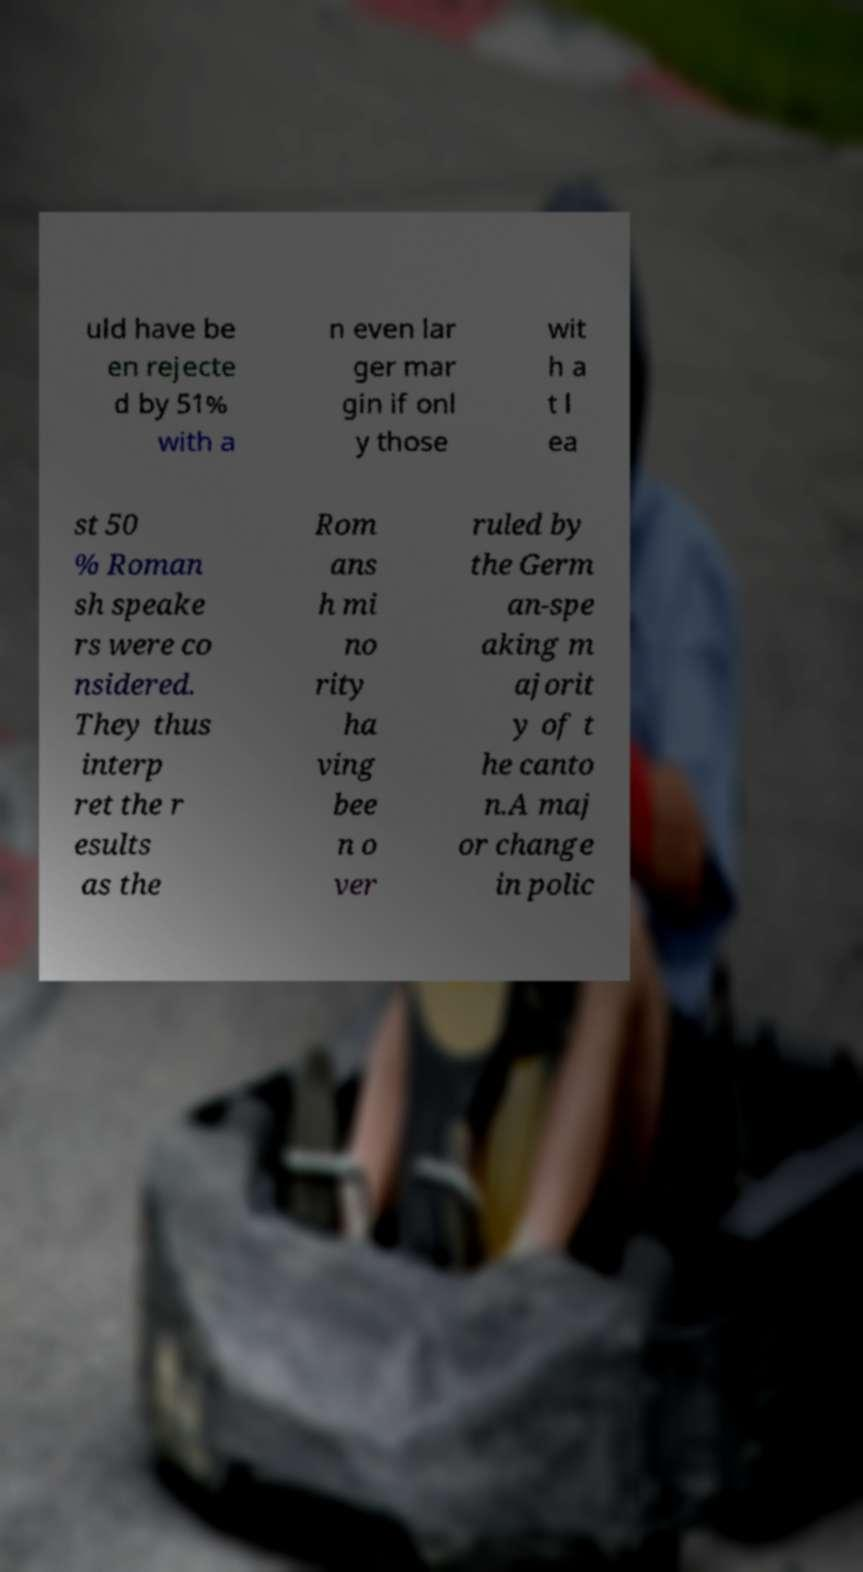For documentation purposes, I need the text within this image transcribed. Could you provide that? uld have be en rejecte d by 51% with a n even lar ger mar gin if onl y those wit h a t l ea st 50 % Roman sh speake rs were co nsidered. They thus interp ret the r esults as the Rom ans h mi no rity ha ving bee n o ver ruled by the Germ an-spe aking m ajorit y of t he canto n.A maj or change in polic 